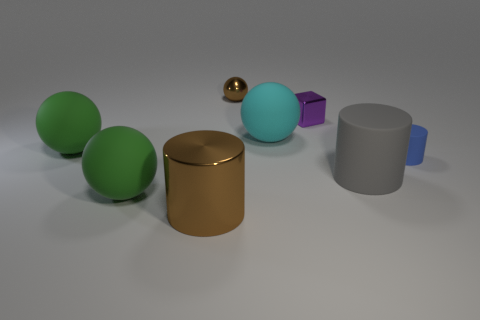Subtract all purple spheres. Subtract all purple cubes. How many spheres are left? 4 Add 1 blue cylinders. How many objects exist? 9 Subtract all cylinders. How many objects are left? 5 Subtract 0 cyan cubes. How many objects are left? 8 Subtract all brown balls. Subtract all blue objects. How many objects are left? 6 Add 4 big spheres. How many big spheres are left? 7 Add 7 brown shiny cylinders. How many brown shiny cylinders exist? 8 